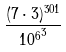Convert formula to latex. <formula><loc_0><loc_0><loc_500><loc_500>\frac { ( 7 \cdot 3 ) ^ { 3 0 1 } } { { 1 0 ^ { 6 } } ^ { 3 } }</formula> 